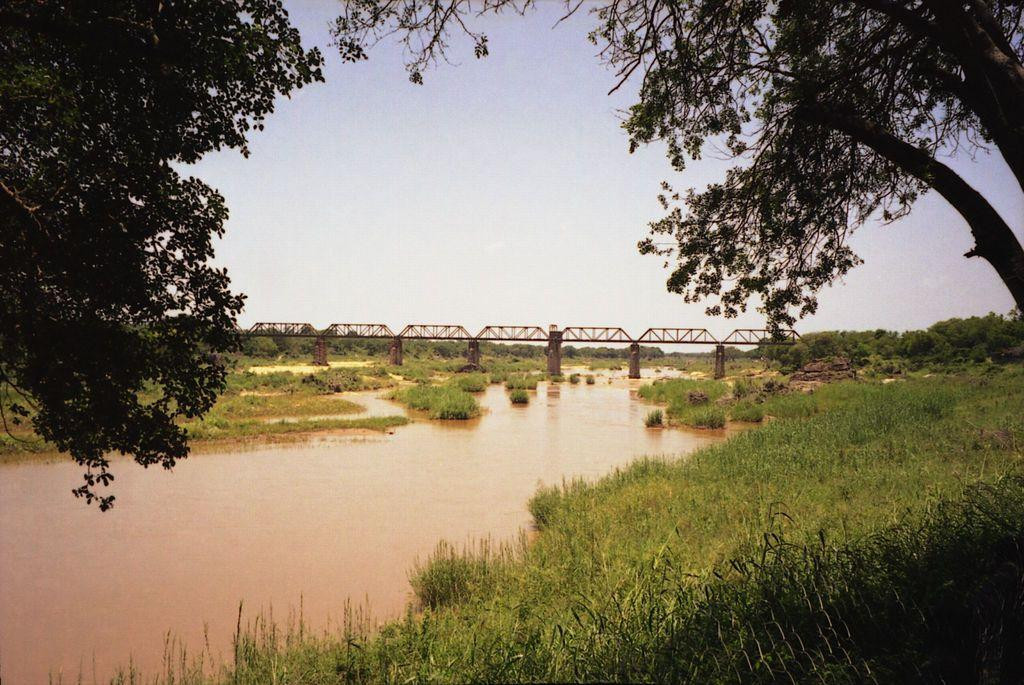What type of structure can be seen in the image? There is a bridge in the image. What natural feature is present near the bridge? There is a river in the image. What can be seen in the sky in the image? The sky is visible in the image. What type of vegetation is present in the image? There are many trees and plants in the image. What time of day is it in the image, considering the position of the sun? The position of the sun is not visible in the image, so it cannot be determined what time of day it is. Is there a cave present in the image? There is no cave visible in the image. 